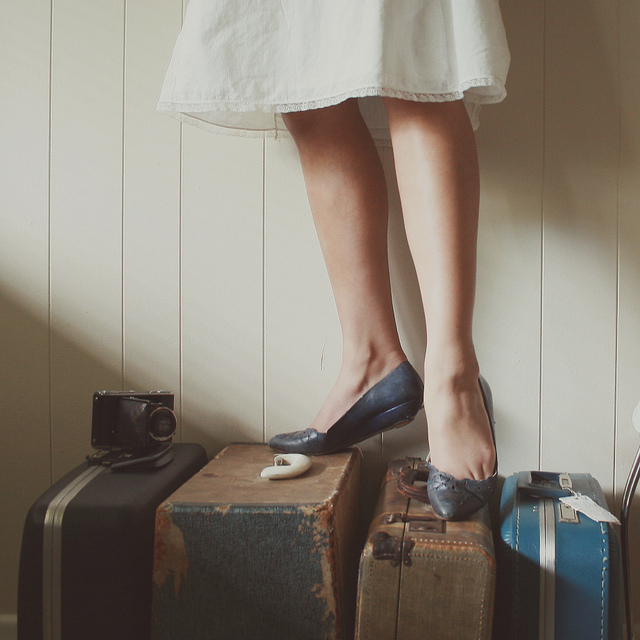What can we infer about the person in the image based on the items and their posture? The posture of the person delicately balanced on suitcases conveys a sense of readiness and poise. The vintage luggage and camera might suggest a fondness for the past or an appreciation for the classic and timeless, potentially pointing to a personality that values history and the stories it tells. The dress and shoes appear stylish yet comfortable, indicating a traveler who values functionality while expressing individuality. 